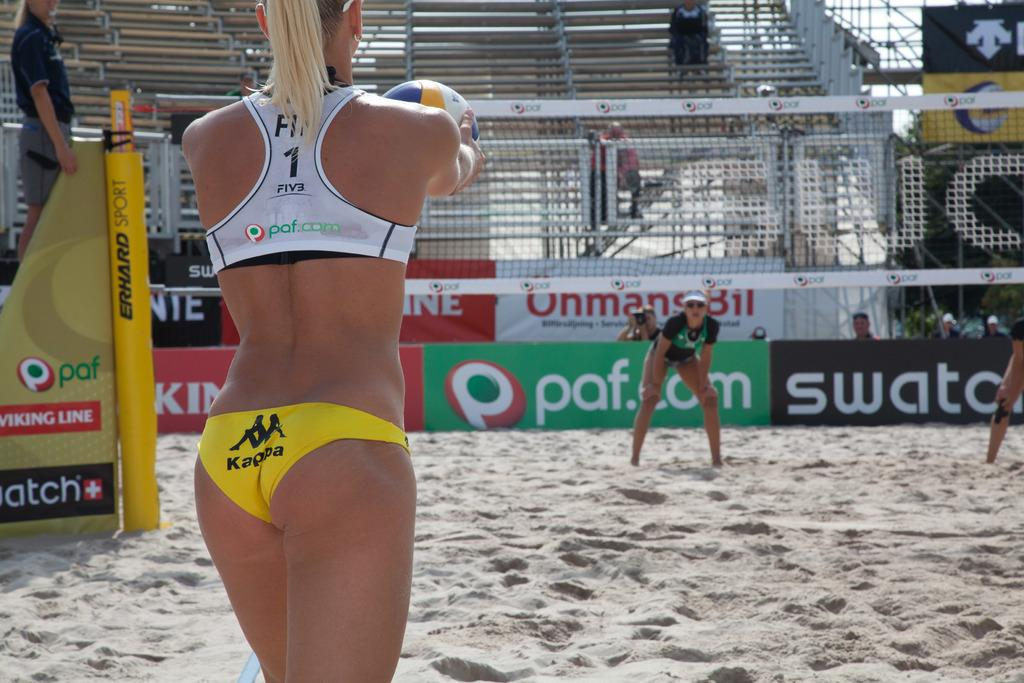Provide a one-sentence caption for the provided image. A woman playing volleyball wearing yellow Kappa bottoms and white Paf top. 